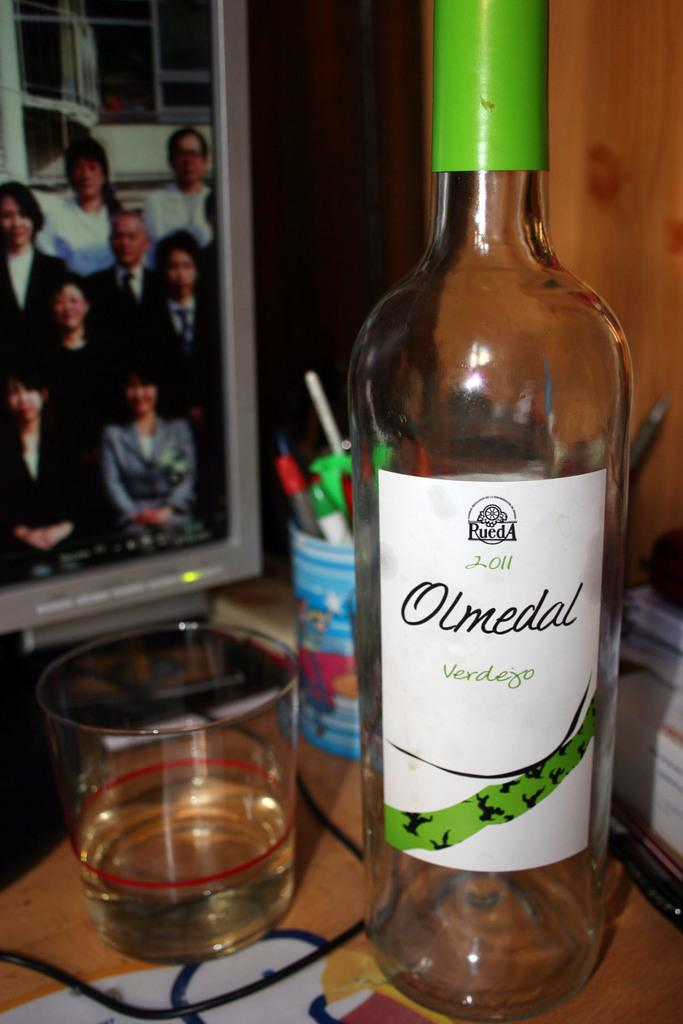What is one object visible in the image? There is a bottle in the image. What else can be seen in the image? There is a glass in the image. Where are the books located in the image? The books are on the right side of the image. What is present in the left top of the image? There is a screen in the left top of the image. What type of flowers can be seen growing near the screen in the image? There are no flowers present in the image; it only features a bottle, a glass, books, and a screen. 